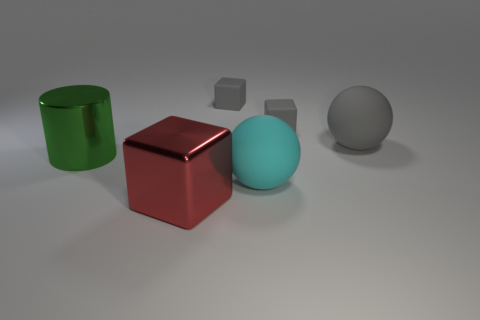How many red spheres are made of the same material as the cyan thing? 0 